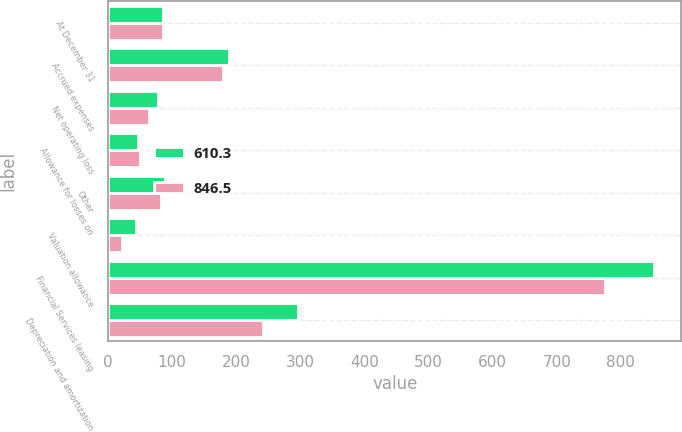Convert chart to OTSL. <chart><loc_0><loc_0><loc_500><loc_500><stacked_bar_chart><ecel><fcel>At December 31<fcel>Accrued expenses<fcel>Net operating loss<fcel>Allowance for losses on<fcel>Other<fcel>Valuation allowance<fcel>Financial Services leasing<fcel>Depreciation and amortization<nl><fcel>610.3<fcel>85.85<fcel>188.4<fcel>78.2<fcel>47<fcel>88.4<fcel>43.9<fcel>851.8<fcel>296.1<nl><fcel>846.5<fcel>85.85<fcel>179.9<fcel>64.2<fcel>50.4<fcel>83.3<fcel>21.2<fcel>775.8<fcel>241.4<nl></chart> 